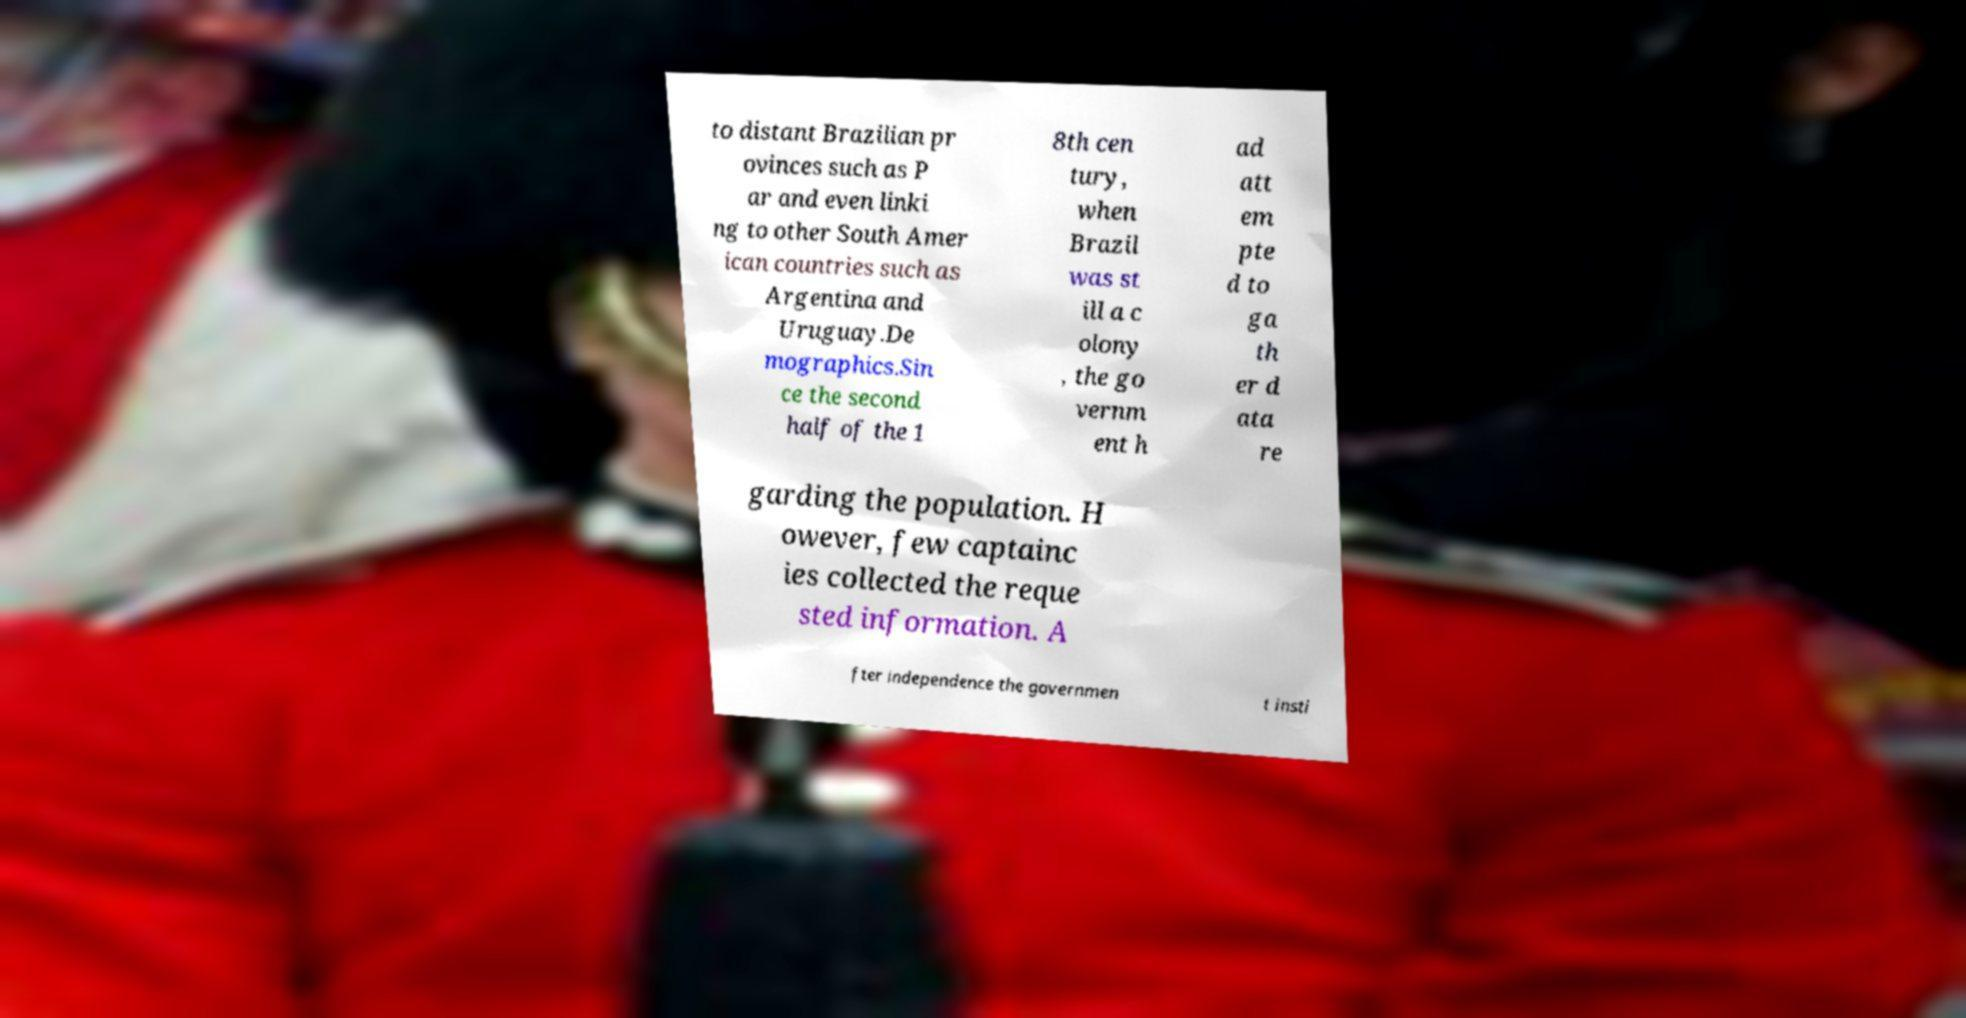What messages or text are displayed in this image? I need them in a readable, typed format. to distant Brazilian pr ovinces such as P ar and even linki ng to other South Amer ican countries such as Argentina and Uruguay.De mographics.Sin ce the second half of the 1 8th cen tury, when Brazil was st ill a c olony , the go vernm ent h ad att em pte d to ga th er d ata re garding the population. H owever, few captainc ies collected the reque sted information. A fter independence the governmen t insti 